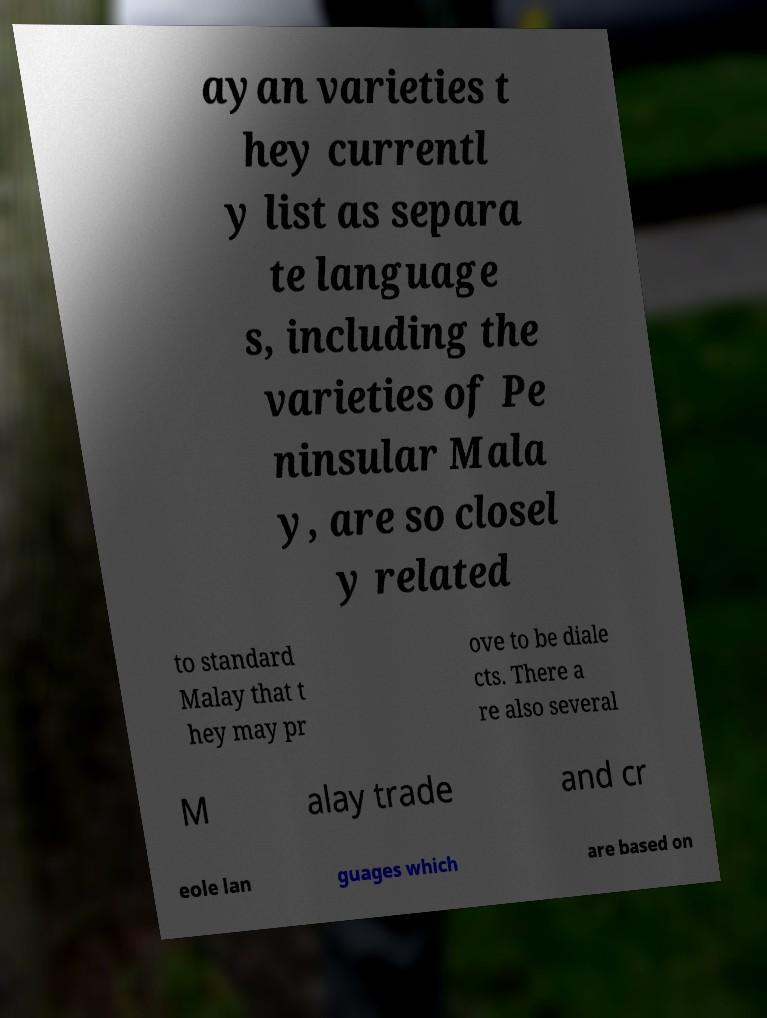Could you assist in decoding the text presented in this image and type it out clearly? ayan varieties t hey currentl y list as separa te language s, including the varieties of Pe ninsular Mala y, are so closel y related to standard Malay that t hey may pr ove to be diale cts. There a re also several M alay trade and cr eole lan guages which are based on 